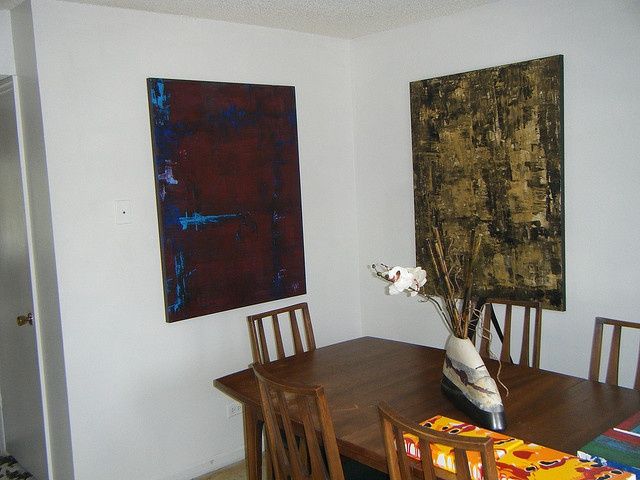Describe the objects in this image and their specific colors. I can see dining table in gray, maroon, and black tones, chair in gray, maroon, black, and brown tones, chair in gray, maroon, brown, and orange tones, chair in gray, darkgray, maroon, and black tones, and vase in gray, black, darkgray, and lightgray tones in this image. 